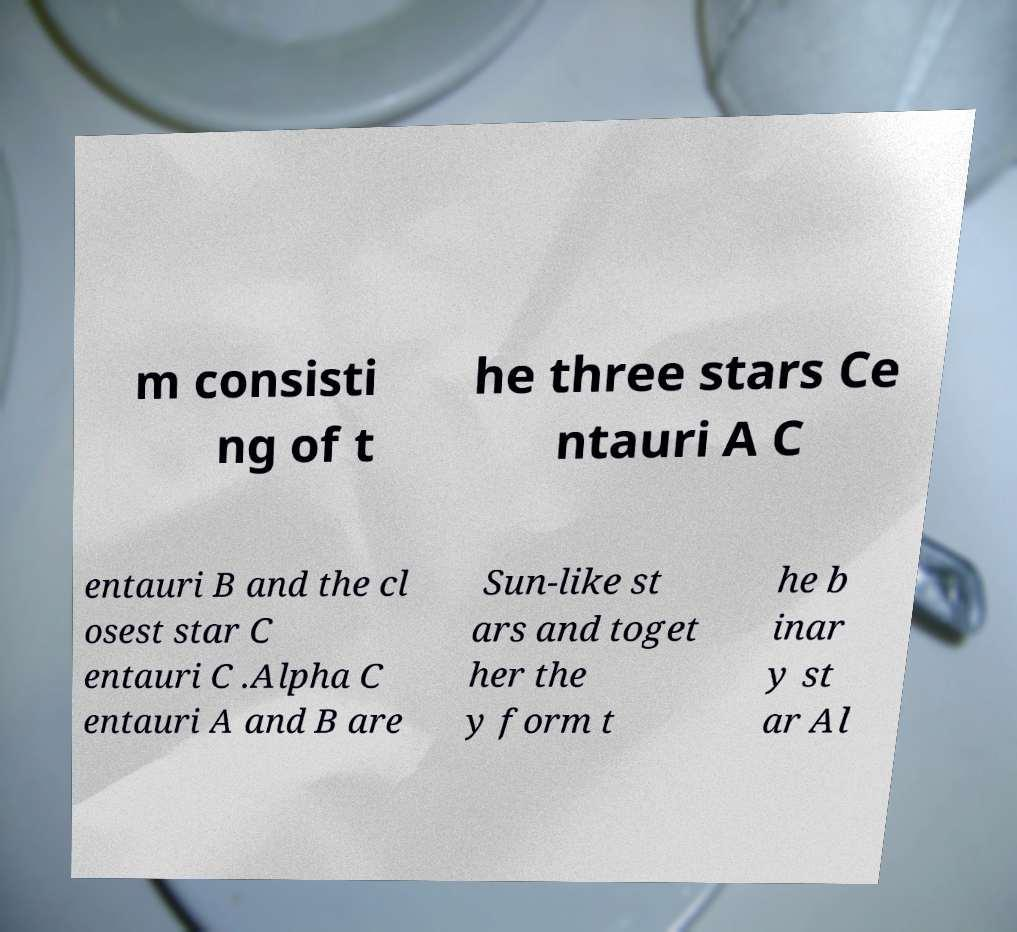Can you read and provide the text displayed in the image?This photo seems to have some interesting text. Can you extract and type it out for me? m consisti ng of t he three stars Ce ntauri A C entauri B and the cl osest star C entauri C .Alpha C entauri A and B are Sun-like st ars and toget her the y form t he b inar y st ar Al 